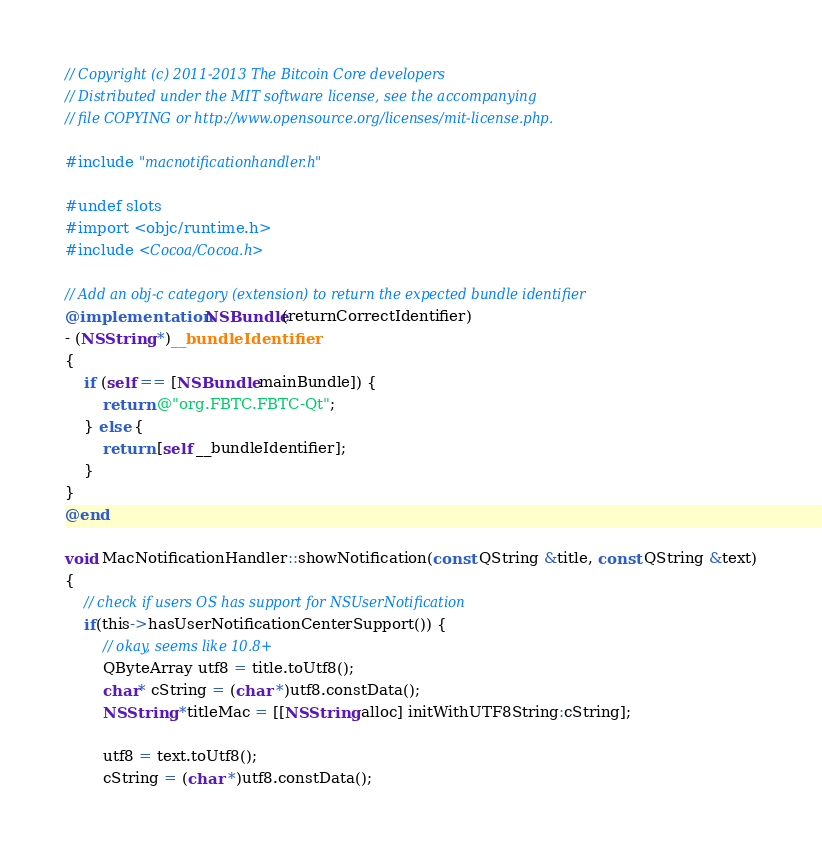Convert code to text. <code><loc_0><loc_0><loc_500><loc_500><_ObjectiveC_>// Copyright (c) 2011-2013 The Bitcoin Core developers
// Distributed under the MIT software license, see the accompanying
// file COPYING or http://www.opensource.org/licenses/mit-license.php.

#include "macnotificationhandler.h"

#undef slots
#import <objc/runtime.h>
#include <Cocoa/Cocoa.h>

// Add an obj-c category (extension) to return the expected bundle identifier
@implementation NSBundle(returnCorrectIdentifier)
- (NSString *)__bundleIdentifier
{
    if (self == [NSBundle mainBundle]) {
        return @"org.FBTC.FBTC-Qt";
    } else {
        return [self __bundleIdentifier];
    }
}
@end

void MacNotificationHandler::showNotification(const QString &title, const QString &text)
{
    // check if users OS has support for NSUserNotification
    if(this->hasUserNotificationCenterSupport()) {
        // okay, seems like 10.8+
        QByteArray utf8 = title.toUtf8();
        char* cString = (char *)utf8.constData();
        NSString *titleMac = [[NSString alloc] initWithUTF8String:cString];

        utf8 = text.toUtf8();
        cString = (char *)utf8.constData();</code> 